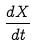<formula> <loc_0><loc_0><loc_500><loc_500>\frac { d X } { d t }</formula> 